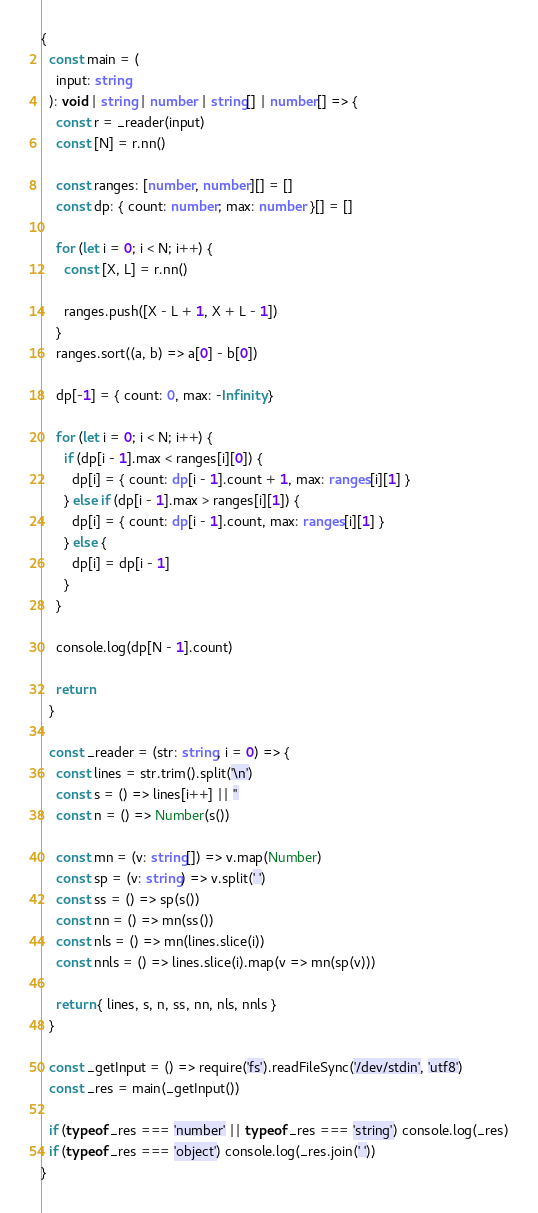Convert code to text. <code><loc_0><loc_0><loc_500><loc_500><_TypeScript_>{
  const main = (
    input: string
  ): void | string | number | string[] | number[] => {
    const r = _reader(input)
    const [N] = r.nn()

    const ranges: [number, number][] = []
    const dp: { count: number; max: number }[] = []

    for (let i = 0; i < N; i++) {
      const [X, L] = r.nn()

      ranges.push([X - L + 1, X + L - 1])
    }
    ranges.sort((a, b) => a[0] - b[0])

    dp[-1] = { count: 0, max: -Infinity }

    for (let i = 0; i < N; i++) {
      if (dp[i - 1].max < ranges[i][0]) {
        dp[i] = { count: dp[i - 1].count + 1, max: ranges[i][1] }
      } else if (dp[i - 1].max > ranges[i][1]) {
        dp[i] = { count: dp[i - 1].count, max: ranges[i][1] }
      } else {
        dp[i] = dp[i - 1]
      }
    }

    console.log(dp[N - 1].count)

    return
  }

  const _reader = (str: string, i = 0) => {
    const lines = str.trim().split('\n')
    const s = () => lines[i++] || ''
    const n = () => Number(s())

    const mn = (v: string[]) => v.map(Number)
    const sp = (v: string) => v.split(' ')
    const ss = () => sp(s())
    const nn = () => mn(ss())
    const nls = () => mn(lines.slice(i))
    const nnls = () => lines.slice(i).map(v => mn(sp(v)))

    return { lines, s, n, ss, nn, nls, nnls }
  }

  const _getInput = () => require('fs').readFileSync('/dev/stdin', 'utf8')
  const _res = main(_getInput())

  if (typeof _res === 'number' || typeof _res === 'string') console.log(_res)
  if (typeof _res === 'object') console.log(_res.join(' '))
}
</code> 